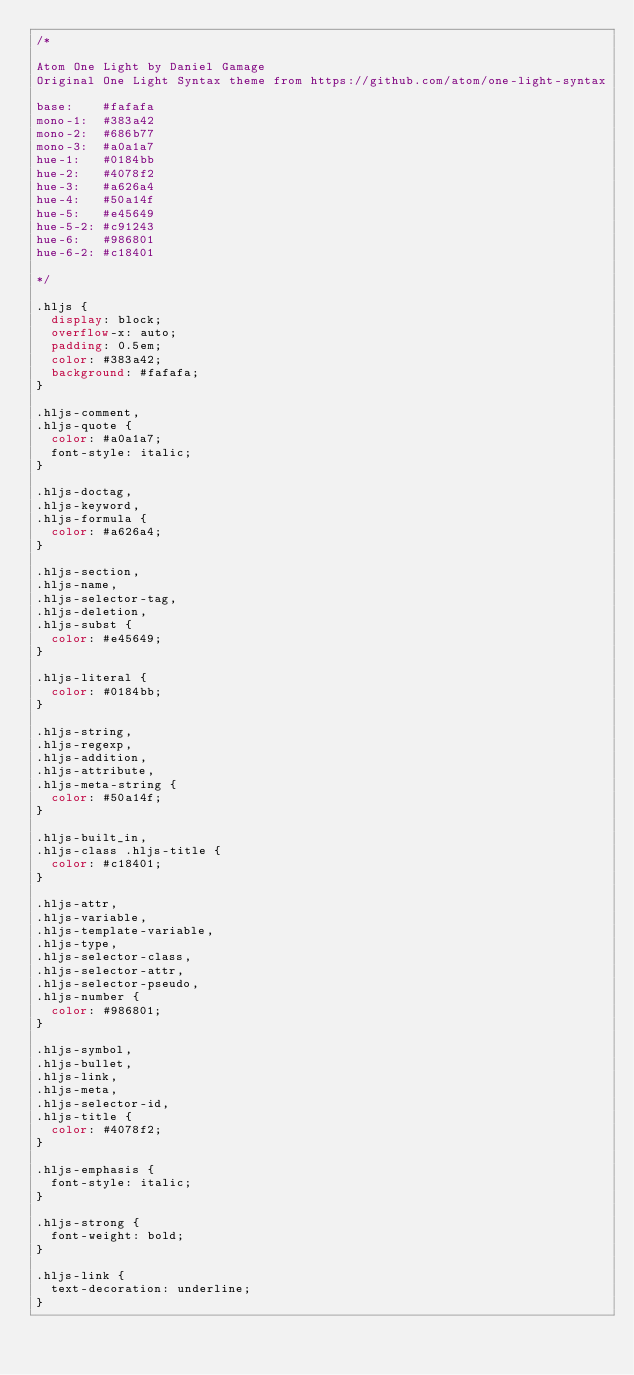<code> <loc_0><loc_0><loc_500><loc_500><_CSS_>/*

Atom One Light by Daniel Gamage
Original One Light Syntax theme from https://github.com/atom/one-light-syntax

base:    #fafafa
mono-1:  #383a42
mono-2:  #686b77
mono-3:  #a0a1a7
hue-1:   #0184bb
hue-2:   #4078f2
hue-3:   #a626a4
hue-4:   #50a14f
hue-5:   #e45649
hue-5-2: #c91243
hue-6:   #986801
hue-6-2: #c18401

*/

.hljs {
  display: block;
  overflow-x: auto;
  padding: 0.5em;
  color: #383a42;
  background: #fafafa;
}

.hljs-comment,
.hljs-quote {
  color: #a0a1a7;
  font-style: italic;
}

.hljs-doctag,
.hljs-keyword,
.hljs-formula {
  color: #a626a4;
}

.hljs-section,
.hljs-name,
.hljs-selector-tag,
.hljs-deletion,
.hljs-subst {
  color: #e45649;
}

.hljs-literal {
  color: #0184bb;
}

.hljs-string,
.hljs-regexp,
.hljs-addition,
.hljs-attribute,
.hljs-meta-string {
  color: #50a14f;
}

.hljs-built_in,
.hljs-class .hljs-title {
  color: #c18401;
}

.hljs-attr,
.hljs-variable,
.hljs-template-variable,
.hljs-type,
.hljs-selector-class,
.hljs-selector-attr,
.hljs-selector-pseudo,
.hljs-number {
  color: #986801;
}

.hljs-symbol,
.hljs-bullet,
.hljs-link,
.hljs-meta,
.hljs-selector-id,
.hljs-title {
  color: #4078f2;
}

.hljs-emphasis {
  font-style: italic;
}

.hljs-strong {
  font-weight: bold;
}

.hljs-link {
  text-decoration: underline;
}
</code> 